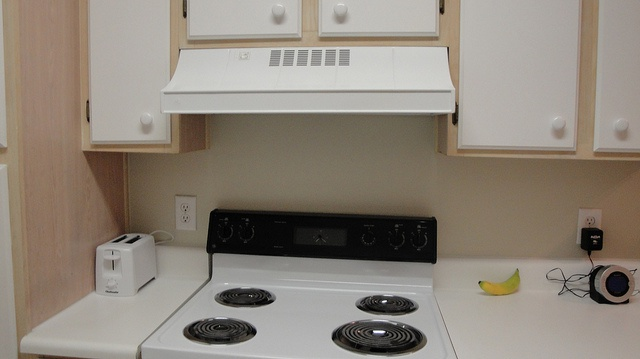Describe the objects in this image and their specific colors. I can see oven in darkgray, black, and gray tones, toaster in darkgray, gray, and black tones, and banana in darkgray and olive tones in this image. 